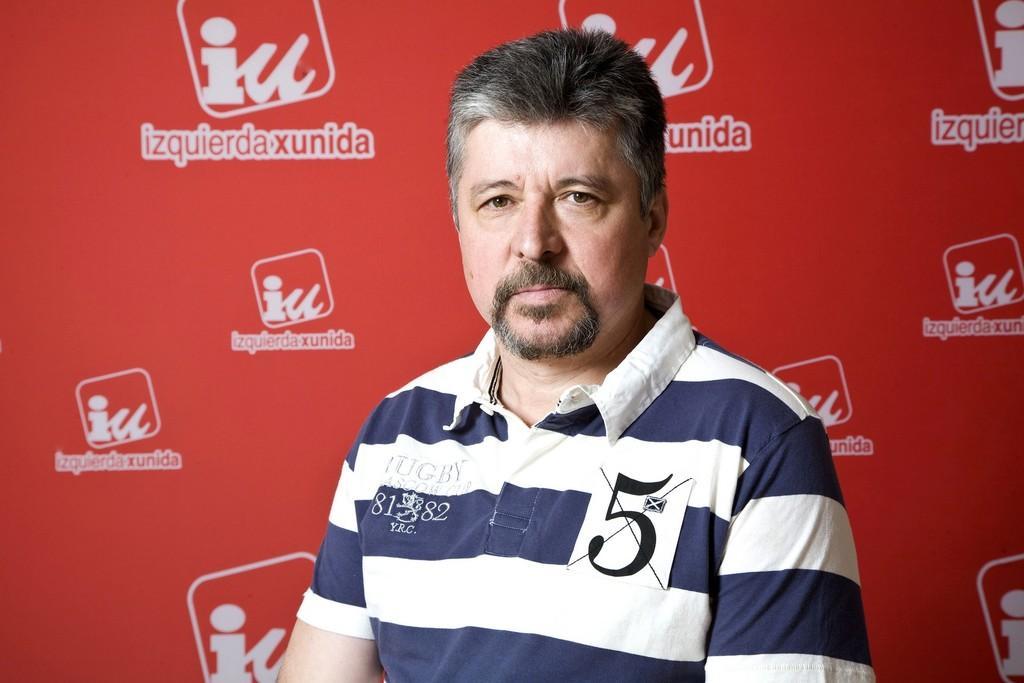Please provide a concise description of this image. In the picture I can see a man wearing blue and white color T-shirt and in the background of the picture there is red color sheet. 